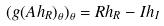<formula> <loc_0><loc_0><loc_500><loc_500>( g ( A h _ { R } ) _ { \theta } ) _ { \theta } = R h _ { R } - I h _ { I }</formula> 